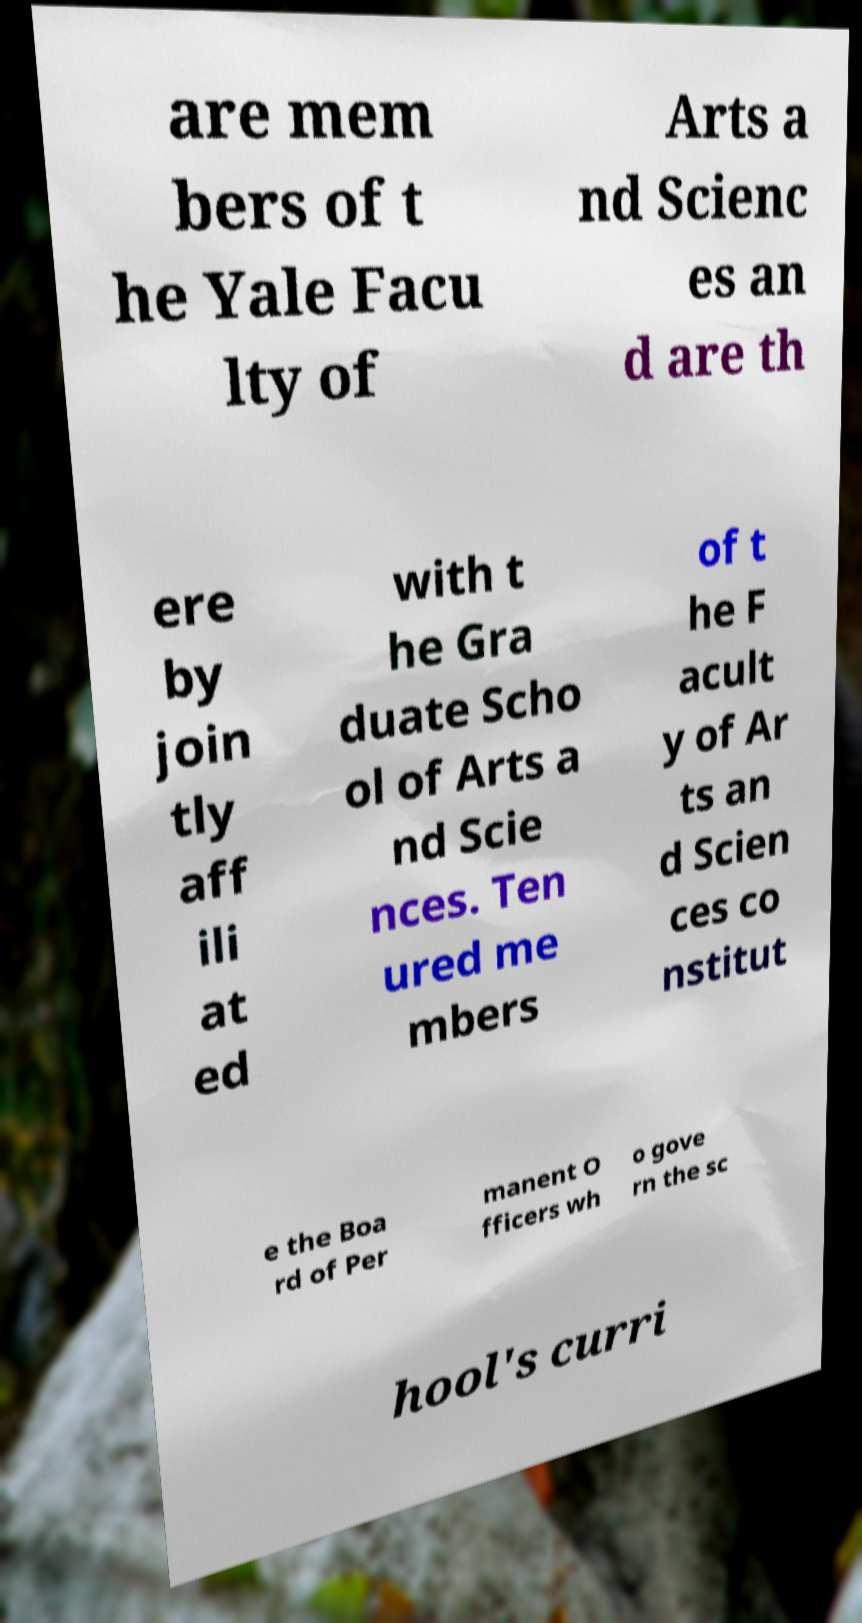I need the written content from this picture converted into text. Can you do that? are mem bers of t he Yale Facu lty of Arts a nd Scienc es an d are th ere by join tly aff ili at ed with t he Gra duate Scho ol of Arts a nd Scie nces. Ten ured me mbers of t he F acult y of Ar ts an d Scien ces co nstitut e the Boa rd of Per manent O fficers wh o gove rn the sc hool's curri 